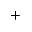<formula> <loc_0><loc_0><loc_500><loc_500>^ { + }</formula> 